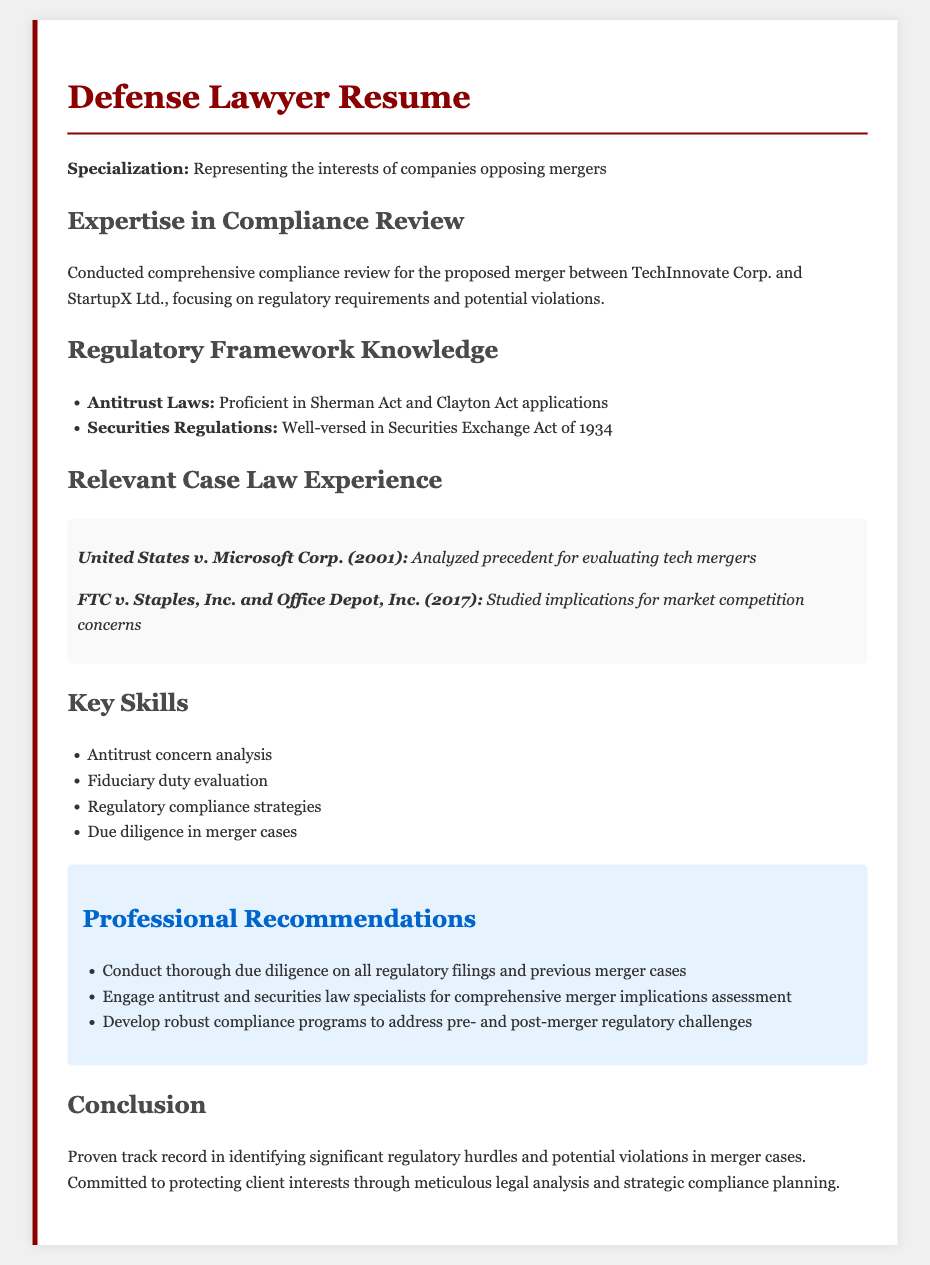What is the name of the company opposing the merger? The company opposing the merger is referenced as "TechInnovate Corp." in the document.
Answer: TechInnovate Corp What is one regulatory framework mentioned in the document? The document lists "Antitrust Laws" as one of the regulatory frameworks.
Answer: Antitrust Laws Which act is mentioned under Securities Regulations? The document mentions the "Securities Exchange Act of 1934" under Securities Regulations.
Answer: Securities Exchange Act of 1934 What year was the United States v. Microsoft Corp. case? The case is stated to have occurred in the year 2001.
Answer: 2001 What type of evaluation is mentioned as a key skill? The document mentions "Fiduciary duty evaluation" as a key skill related to compliance review.
Answer: Fiduciary duty evaluation How many recommendations are provided in the resume? There are three recommendations listed in the document under the Professional Recommendations section.
Answer: Three What type of legal issues does the lawyer have a proven track record in identifying? The lawyer has a proven track record in identifying "significant regulatory hurdles" related to merger cases.
Answer: Significant regulatory hurdles What is the primary focus of the compliance review conducted? The focus of the compliance review is on "regulatory requirements and potential violations."
Answer: Regulatory requirements and potential violations Which FTC case is analyzed for market competition concerns? The document references "FTC v. Staples, Inc. and Office Depot, Inc. (2017)" regarding market competition concerns.
Answer: FTC v. Staples, Inc. and Office Depot, Inc. (2017) 